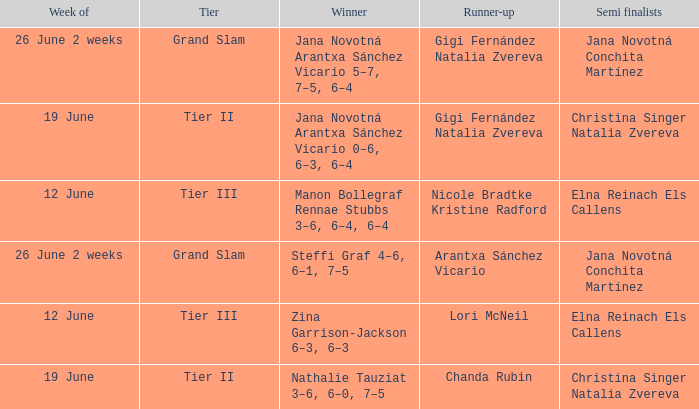When the Tier is listed as tier iii, who is the Winner? Zina Garrison-Jackson 6–3, 6–3, Manon Bollegraf Rennae Stubbs 3–6, 6–4, 6–4. 